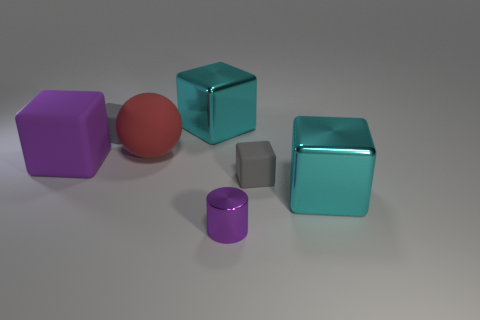What function do you think these objects might serve in a real-world setting? Considering their simple geometric shapes and uniformity, these items could be educational tools for teaching concepts such as volume, geometry, or for use in sensory development exercises, particularly for children. 